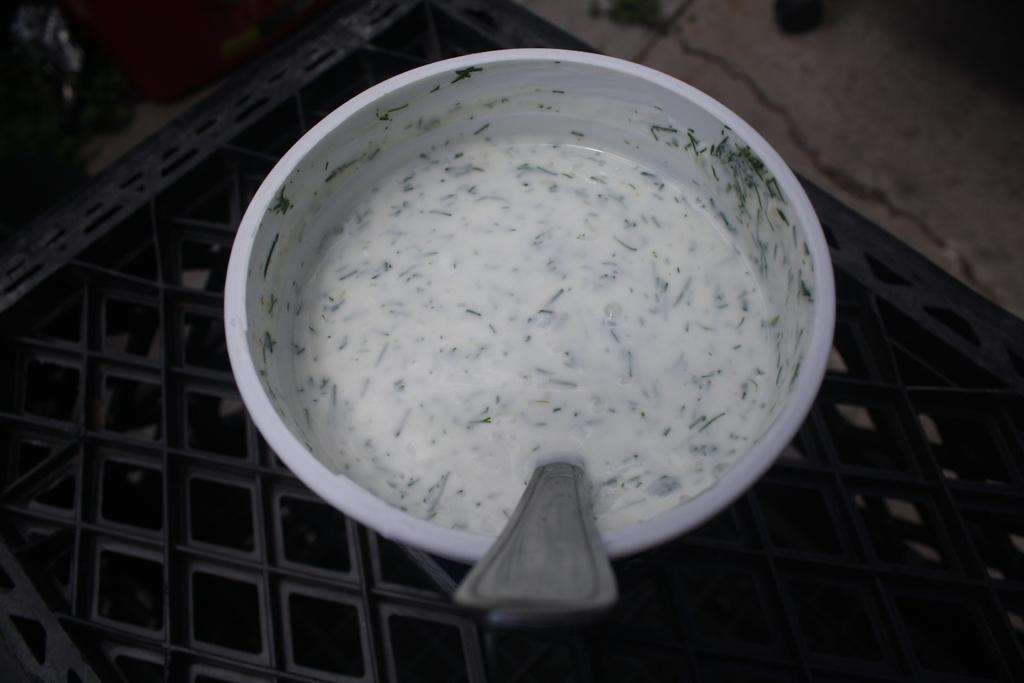What is in the bowl that is visible in the image? There is a bowl with soup in the image. What utensil is present in the image? There is a spoon in the image. Where is the bowl placed? The bowl is placed on a grill. How many orders of soup can be seen in the image? There is no reference to multiple orders of soup in the image; it only shows one bowl of soup. 